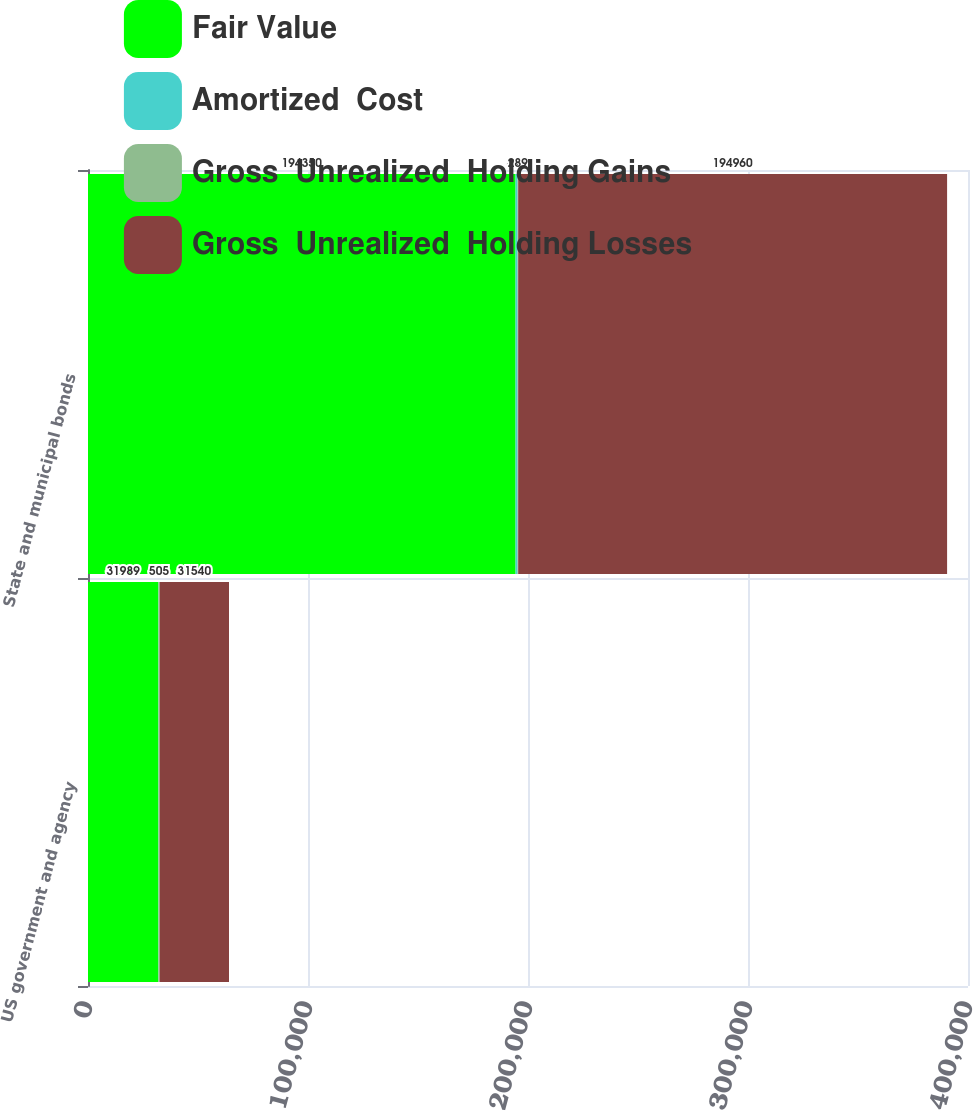Convert chart to OTSL. <chart><loc_0><loc_0><loc_500><loc_500><stacked_bar_chart><ecel><fcel>US government and agency<fcel>State and municipal bonds<nl><fcel>Fair Value<fcel>31989<fcel>194350<nl><fcel>Amortized  Cost<fcel>56<fcel>899<nl><fcel>Gross  Unrealized  Holding Gains<fcel>505<fcel>289<nl><fcel>Gross  Unrealized  Holding Losses<fcel>31540<fcel>194960<nl></chart> 